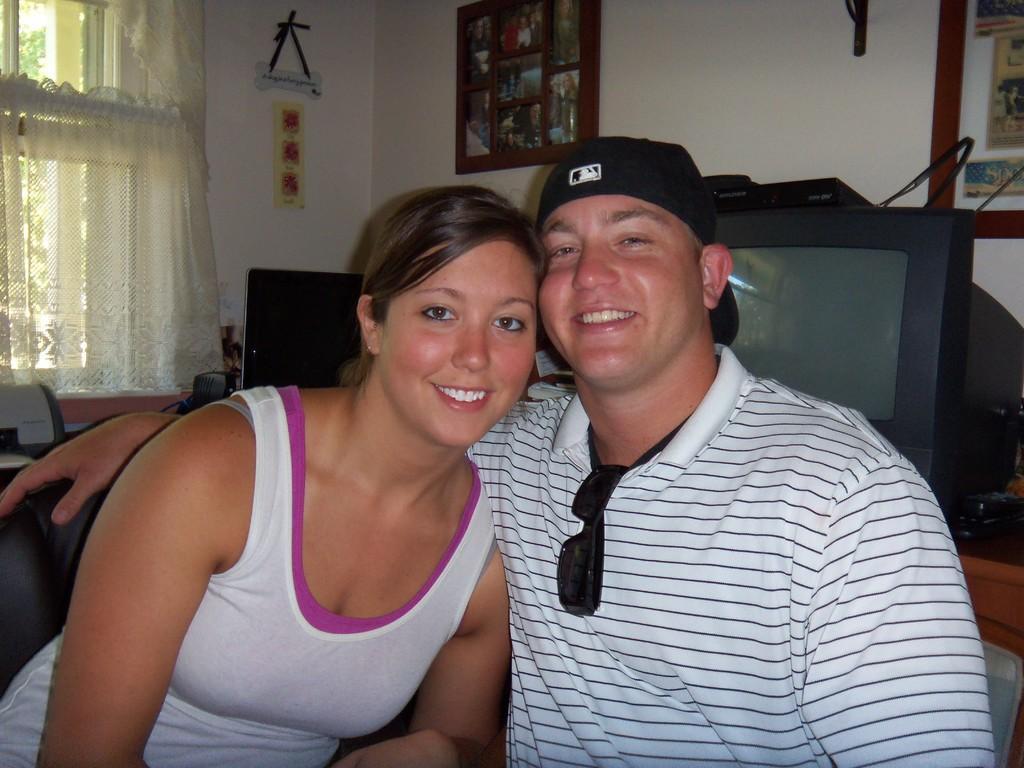Describe this image in one or two sentences. In this image a man and a woman are sitting. They both are smiling. In the background there is TV, on the table few other things are there. On the wall there are frames, hangings. In the top left there is a window with curtains. 